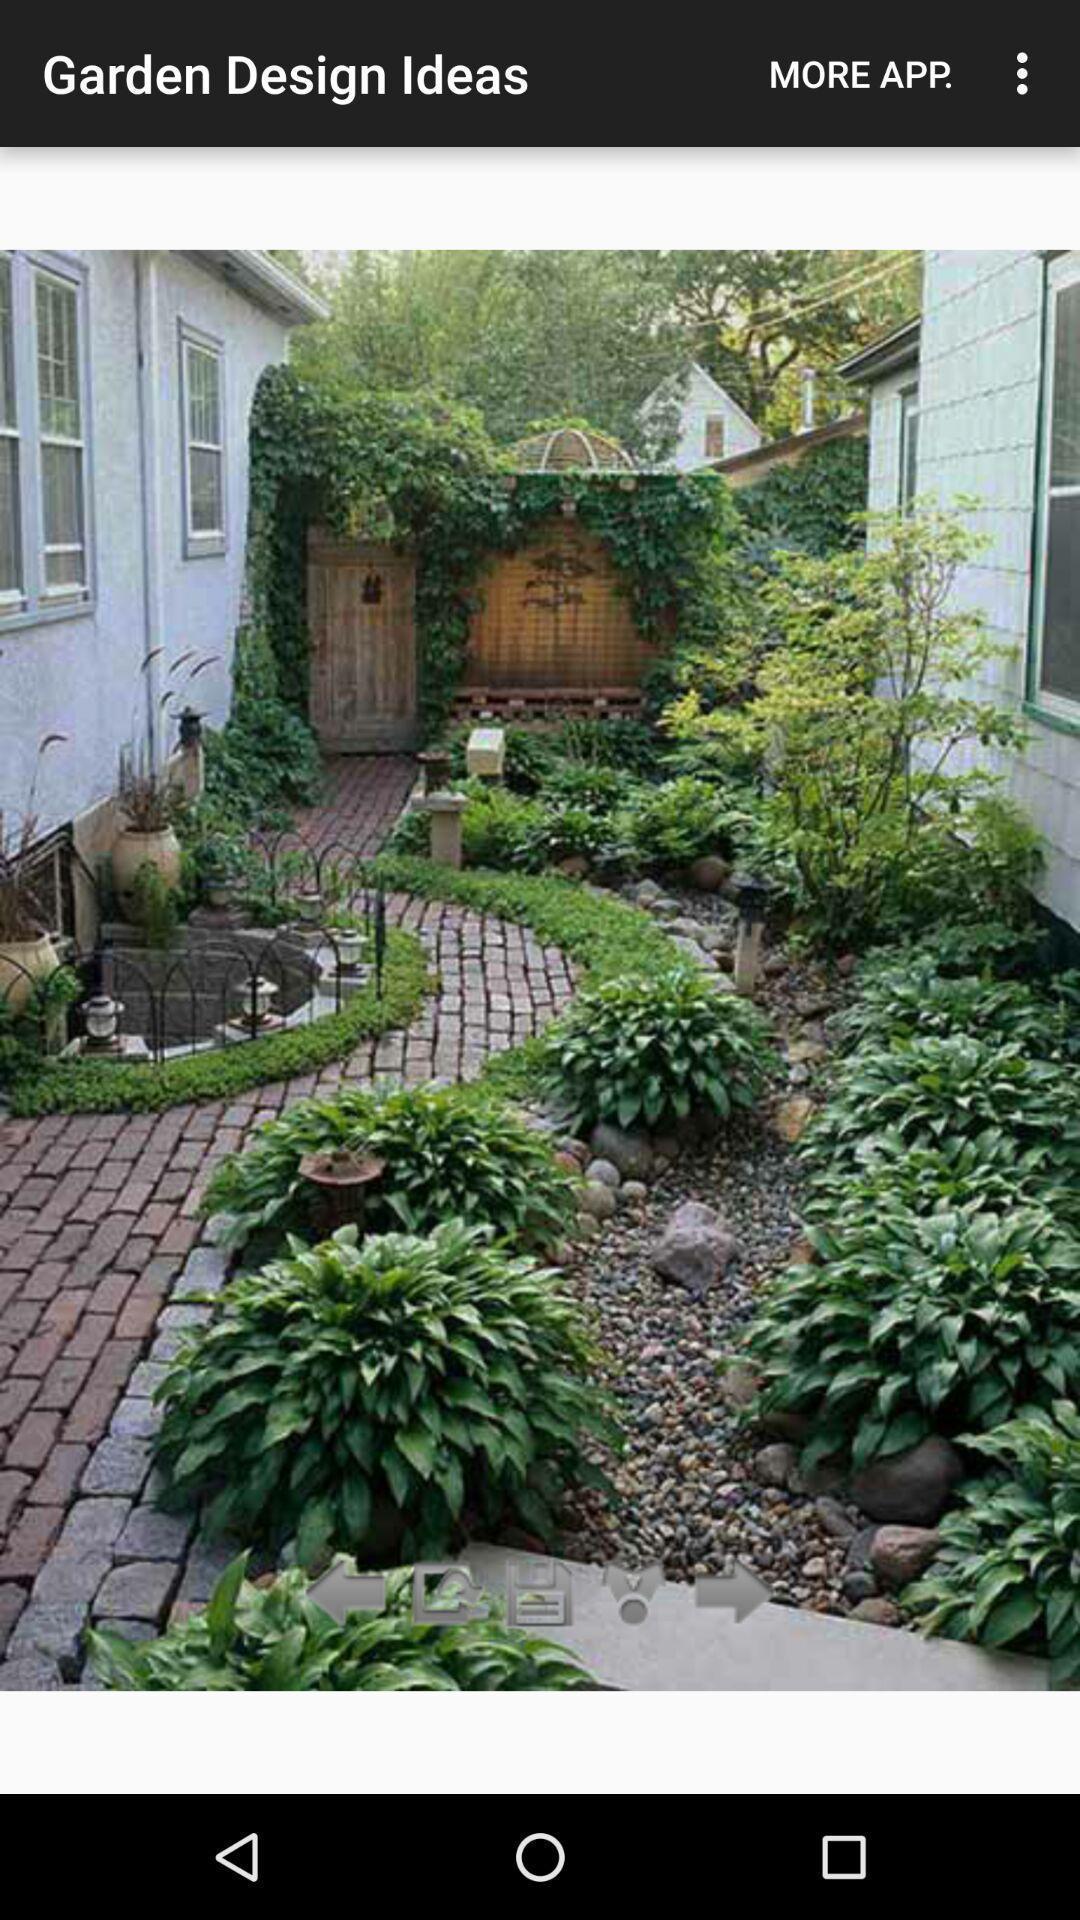Provide a detailed account of this screenshot. Window displaying ideas for garden. 